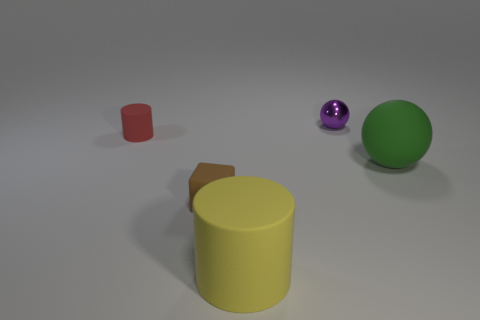Are there more green matte objects that are on the left side of the large yellow matte object than brown objects behind the matte cube?
Your answer should be very brief. No. There is a tiny object that is both behind the green object and in front of the purple metal sphere; what material is it made of?
Your answer should be very brief. Rubber. What is the color of the matte thing that is the same shape as the small purple shiny thing?
Provide a succinct answer. Green. What size is the brown matte object?
Provide a short and direct response. Small. What is the color of the big thing to the right of the large matte thing that is left of the purple sphere?
Your response must be concise. Green. How many objects are both in front of the small red cylinder and to the left of the yellow object?
Your response must be concise. 1. Is the number of brown blocks greater than the number of big blue matte cylinders?
Your answer should be compact. Yes. What is the tiny red object made of?
Make the answer very short. Rubber. What number of purple spheres are right of the tiny object that is left of the cube?
Provide a succinct answer. 1. Does the tiny ball have the same color as the cylinder that is behind the yellow rubber cylinder?
Provide a succinct answer. No. 